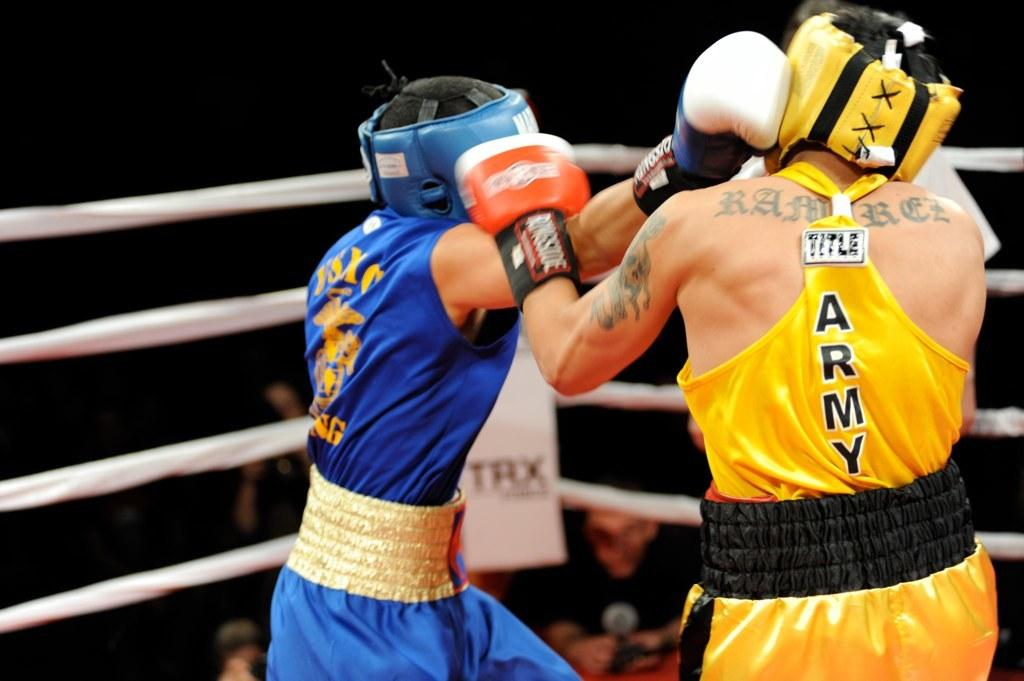What is happening in the image? There is a boxing match between two men in the image. Where is the boxing match taking place? The match is taking place in a ring. Are there any spectators or other people present in the image? Yes, there are people standing near the ring. What type of prison can be seen in the background of the image? There is no prison present in the image; it features a boxing match taking place in a ring. How many drops of water can be seen falling from the ceiling in the image? There is no mention of water or a ceiling in the image, so it is not possible to determine the number of drops. 